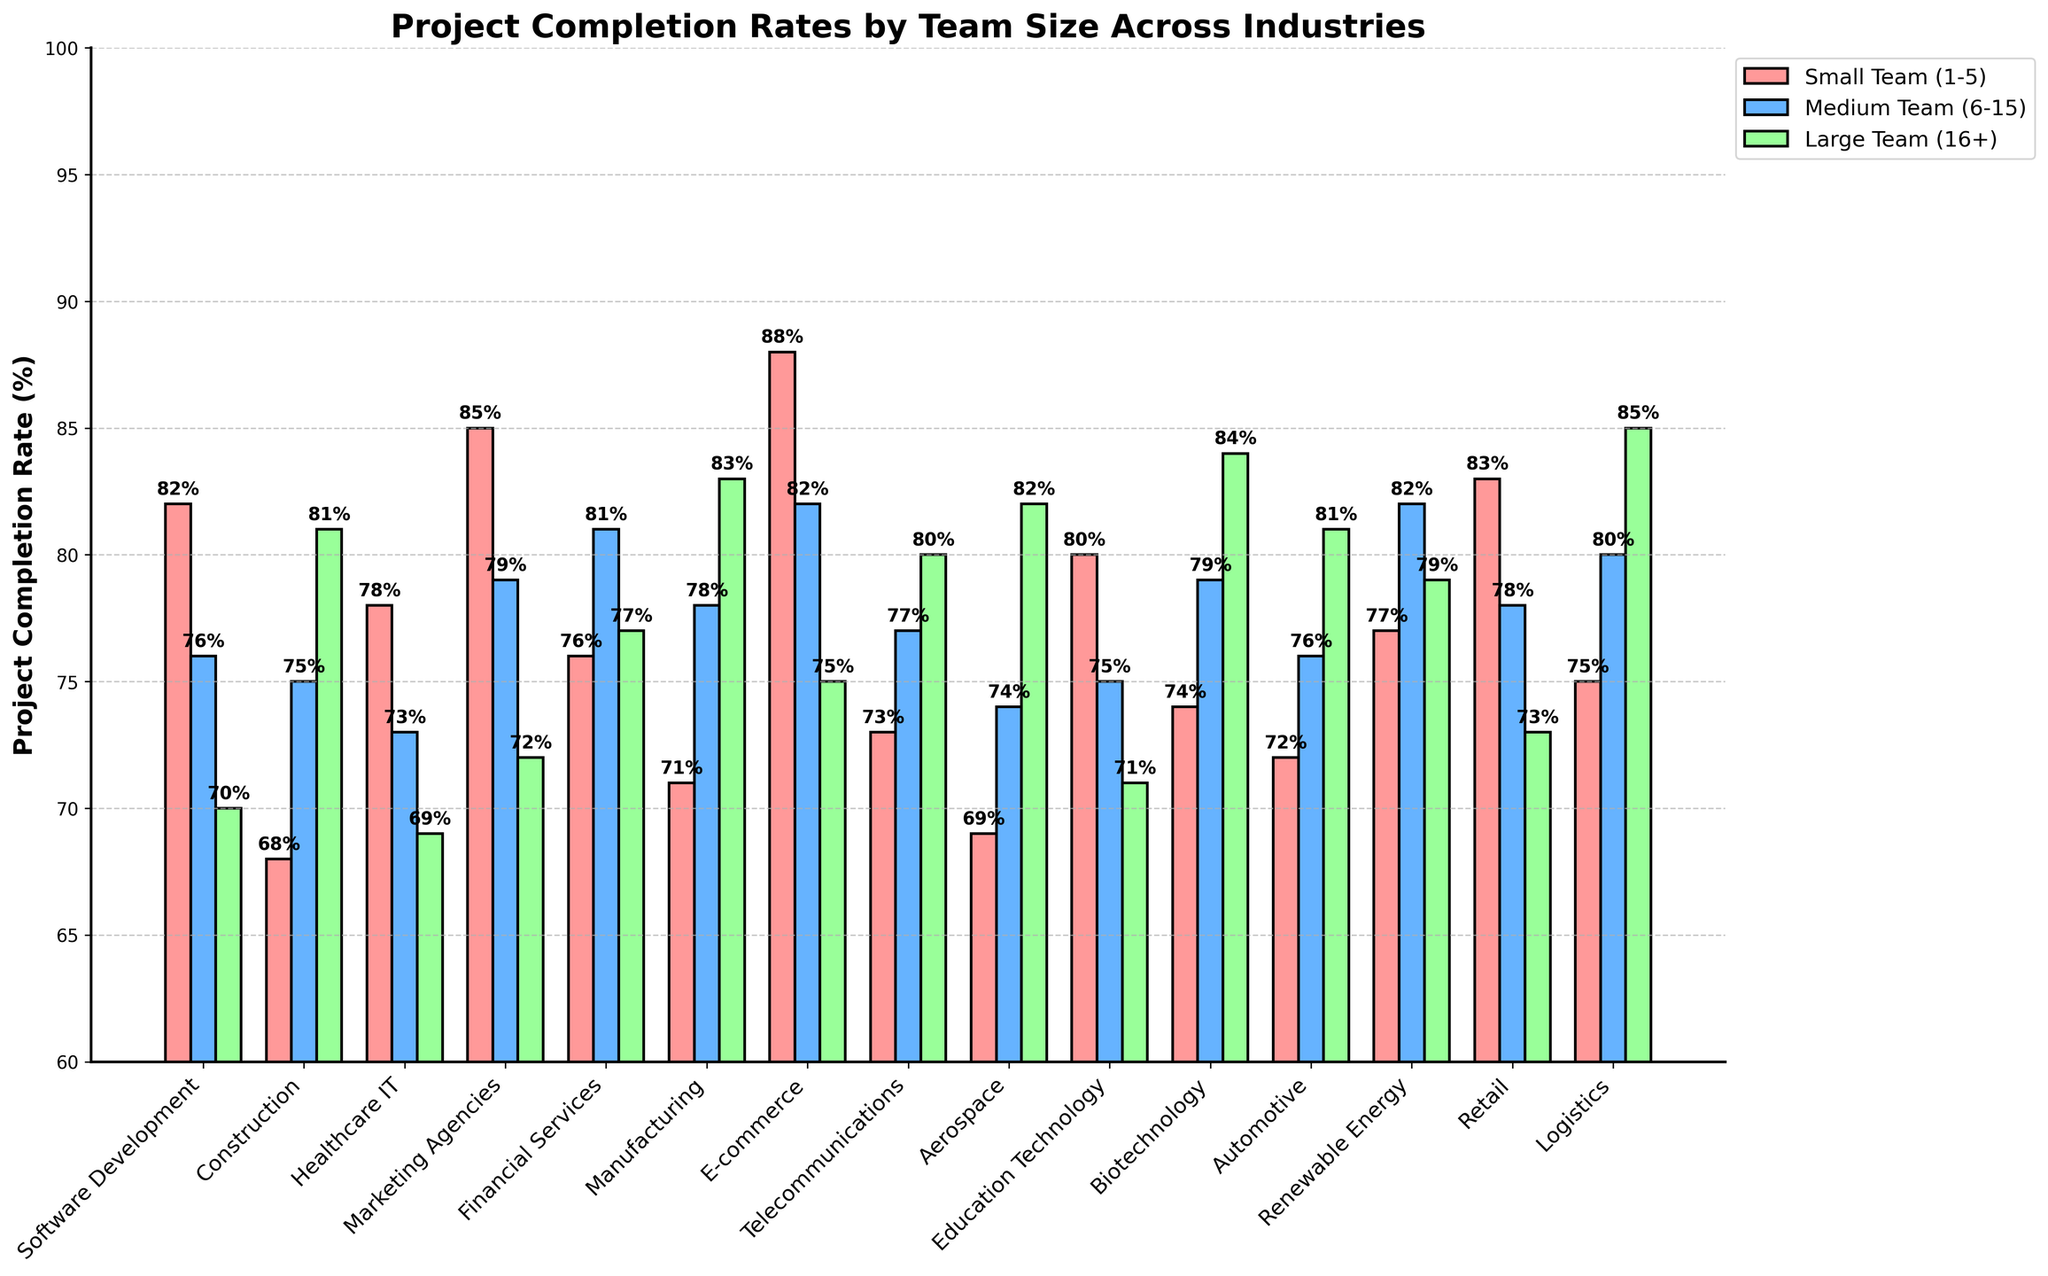Which industry has the highest project completion rate for small teams (1-5)? To find the answer, look at the bars representing small teams (1-5) in different industries and identify the tallest one. In this case, the red bar in E-commerce is the highest with a completion rate of 88%.
Answer: E-commerce Which team size in the Biotechnology industry has the highest completion rate? Check the three bars for each team size within the Biotechnology industry. The green bar, which represents large teams (16+), has the highest completion rate with 84%.
Answer: Large Team (16+) What is the average project completion rate for medium teams (6-15) across all industries? Sum up all the numerical values for medium teams (6-15) and divide by the number of industries. The values are (76+75+73+79+81+78+82+77+74+75+79+76+82+78+80) which sum to 1185. There are 15 industries, so the average is 1185/15 = 79%.
Answer: 79% Compare the completion rates for small teams (1-5) and large teams (16+) in the Construction industry. Which is higher and by how much? In the Construction industry, the small team (1-5) rate is 68% and the large team (16+) rate is 81%. Subtract 68 from 81 to find the difference: 81 - 68 = 13%. The large team rate is 13% higher.
Answer: Large teams by 13% Which team size performs the best in Renewable Energy in terms of project completion? By examining the three bars in the Renewable Energy category, the medium team (6-15) bar is the highest with an 82% completion rate.
Answer: Medium Team (6-15) What is the difference in project completion rates between large teams (16+) and small teams (1-5) in the Marketing Agencies industry? The project completion rate for large teams (16+) in Marketing Agencies is 72%, and for small teams (1-5) it is 85%. The difference is 85 - 72 = 13%.
Answer: 13% Does the Automotive industry have higher project completion rates for medium teams (6-15) or small teams (1-5)? In the Automotive industry, the medium team (6-15) rate is 76%, while the small team (1-5) rate is 72%. The medium team rate is higher.
Answer: Medium teams (6-15) In the Telecommunications industry, which team size has the lowest project completion rate? Look at the three bars for the Telecommunications industry and find the shortest one. The small team (1-5) has the lowest completion rate with 73%.
Answer: Small Team (1-5) How many industries have a project completion rate of 80% or higher for large teams (16+)? Count the green bars for large teams (16+) that are at 80% or higher. These industries are Construction (81%), Manufacturing (83%), Aerospace (82%), Biotechnology (84%), Automotive (81%), Telecommunications (80%), and Logistics (85%). There are 7 industries.
Answer: 7 By how much does the project completion rate of small teams (1-5) in Software Development differ from large teams (16+) in the same industry? The completion rate for small teams (1-5) in Software Development is 82%, while for large teams (16+), it is 70%. To find the difference, subtract 70 from 82: 82 - 70 = 12%.
Answer: 12% 